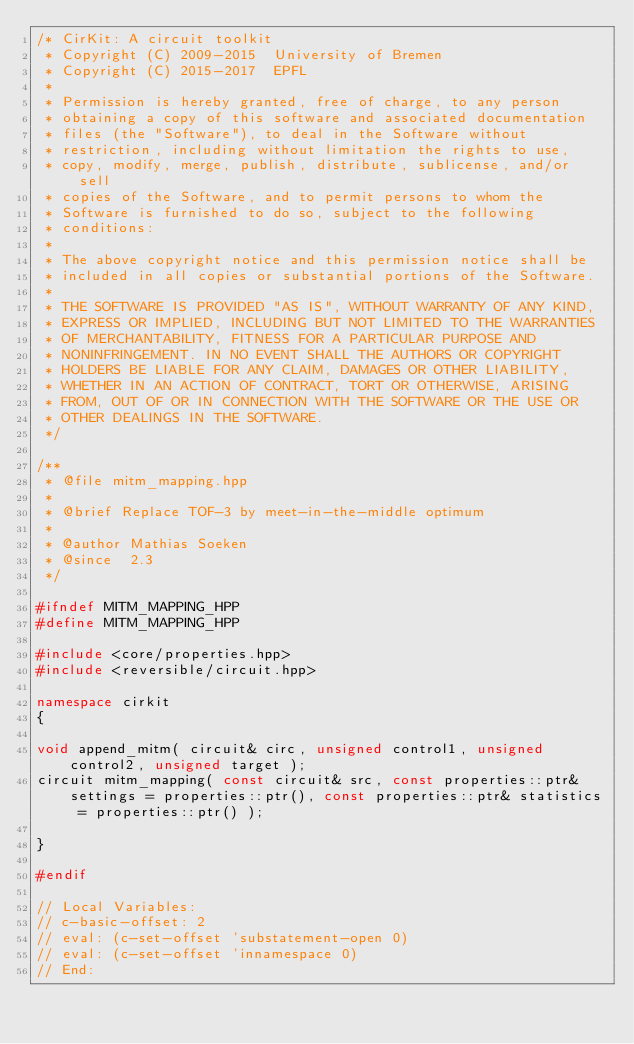Convert code to text. <code><loc_0><loc_0><loc_500><loc_500><_C++_>/* CirKit: A circuit toolkit
 * Copyright (C) 2009-2015  University of Bremen
 * Copyright (C) 2015-2017  EPFL
 *
 * Permission is hereby granted, free of charge, to any person
 * obtaining a copy of this software and associated documentation
 * files (the "Software"), to deal in the Software without
 * restriction, including without limitation the rights to use,
 * copy, modify, merge, publish, distribute, sublicense, and/or sell
 * copies of the Software, and to permit persons to whom the
 * Software is furnished to do so, subject to the following
 * conditions:
 *
 * The above copyright notice and this permission notice shall be
 * included in all copies or substantial portions of the Software.
 *
 * THE SOFTWARE IS PROVIDED "AS IS", WITHOUT WARRANTY OF ANY KIND,
 * EXPRESS OR IMPLIED, INCLUDING BUT NOT LIMITED TO THE WARRANTIES
 * OF MERCHANTABILITY, FITNESS FOR A PARTICULAR PURPOSE AND
 * NONINFRINGEMENT. IN NO EVENT SHALL THE AUTHORS OR COPYRIGHT
 * HOLDERS BE LIABLE FOR ANY CLAIM, DAMAGES OR OTHER LIABILITY,
 * WHETHER IN AN ACTION OF CONTRACT, TORT OR OTHERWISE, ARISING
 * FROM, OUT OF OR IN CONNECTION WITH THE SOFTWARE OR THE USE OR
 * OTHER DEALINGS IN THE SOFTWARE.
 */

/**
 * @file mitm_mapping.hpp
 *
 * @brief Replace TOF-3 by meet-in-the-middle optimum
 *
 * @author Mathias Soeken
 * @since  2.3
 */

#ifndef MITM_MAPPING_HPP
#define MITM_MAPPING_HPP

#include <core/properties.hpp>
#include <reversible/circuit.hpp>

namespace cirkit
{

void append_mitm( circuit& circ, unsigned control1, unsigned control2, unsigned target );
circuit mitm_mapping( const circuit& src, const properties::ptr& settings = properties::ptr(), const properties::ptr& statistics = properties::ptr() );

}

#endif

// Local Variables:
// c-basic-offset: 2
// eval: (c-set-offset 'substatement-open 0)
// eval: (c-set-offset 'innamespace 0)
// End:
</code> 